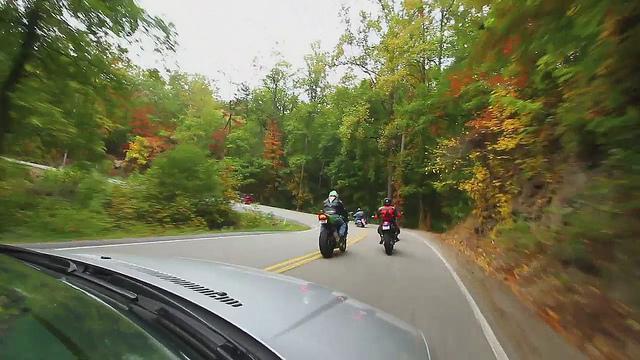How many motorcycles are on the highway apparently ahead of the vehicle driving?
Select the accurate response from the four choices given to answer the question.
Options: Four, six, two, three. Three. 